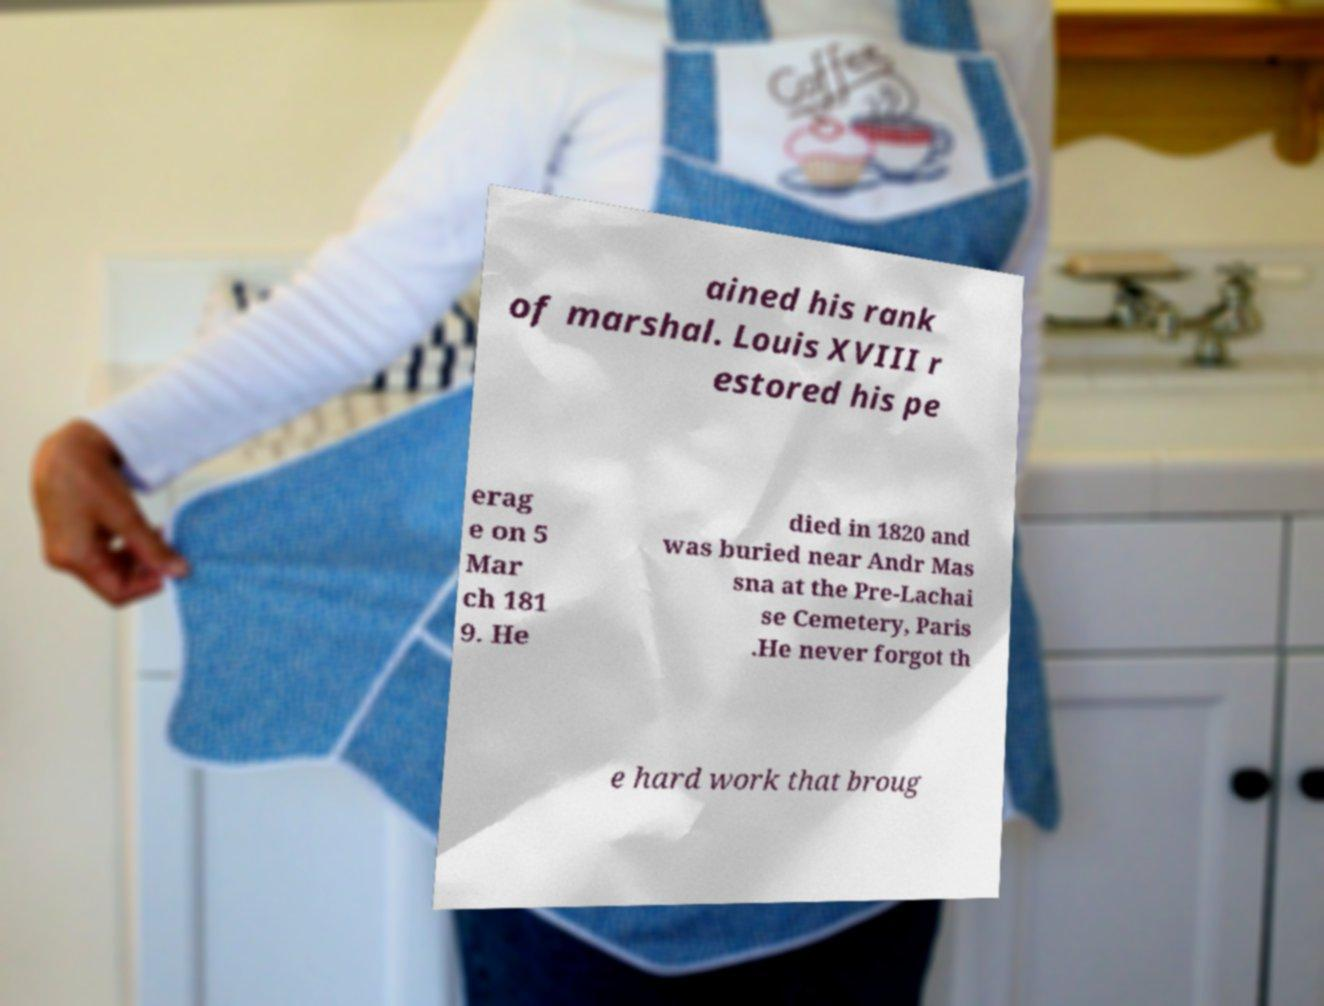Can you read and provide the text displayed in the image?This photo seems to have some interesting text. Can you extract and type it out for me? ained his rank of marshal. Louis XVIII r estored his pe erag e on 5 Mar ch 181 9. He died in 1820 and was buried near Andr Mas sna at the Pre-Lachai se Cemetery, Paris .He never forgot th e hard work that broug 